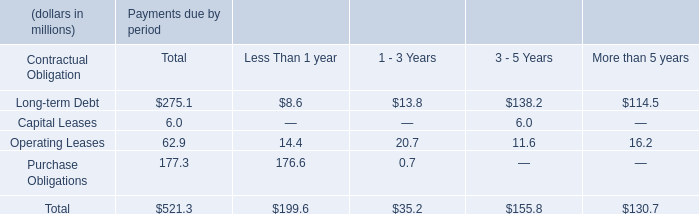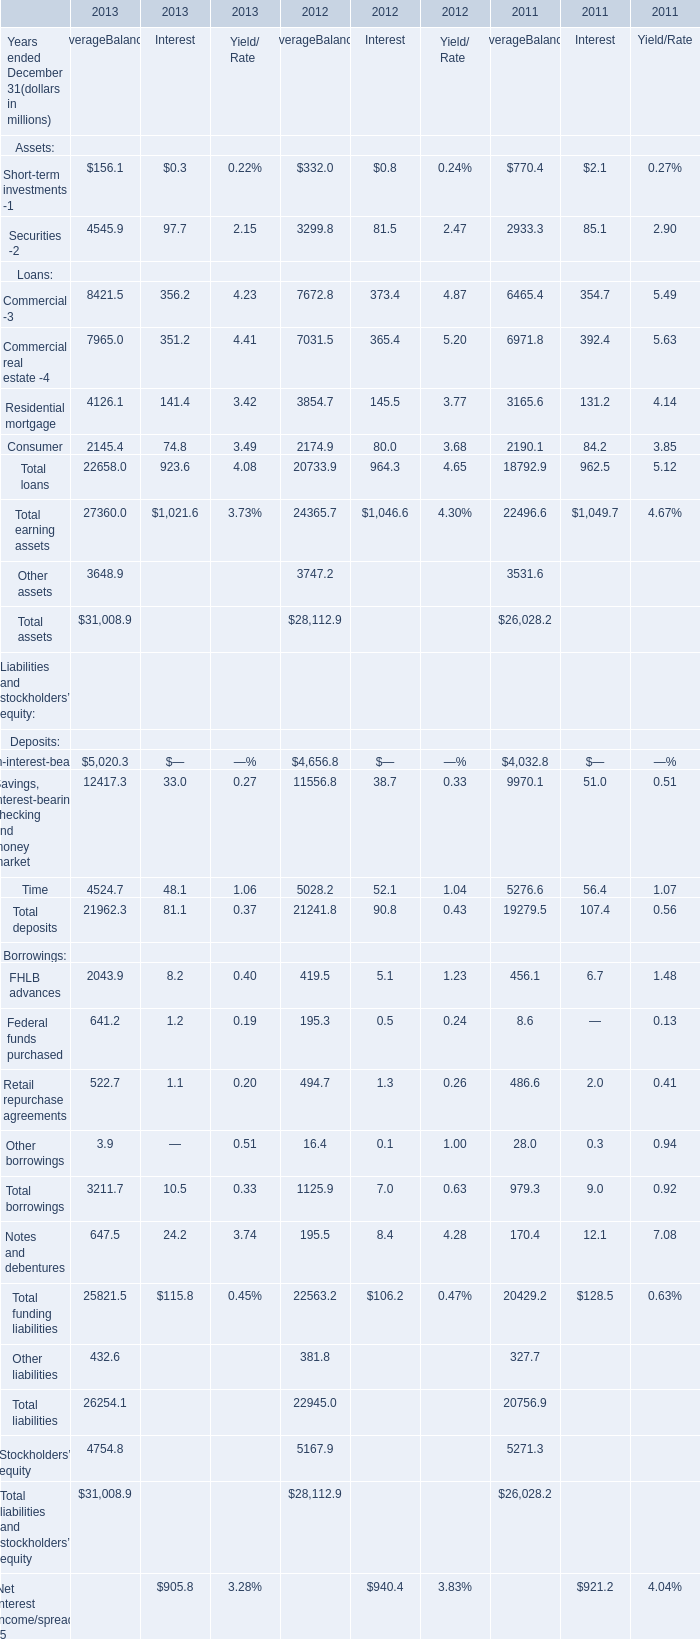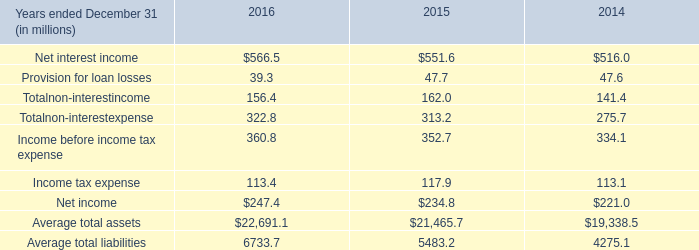What's the Average Balance for Total assets in the year ended December 31 where Average Balance for Other assets is greater than 3700 million? (in million) 
Answer: 28112.9. 